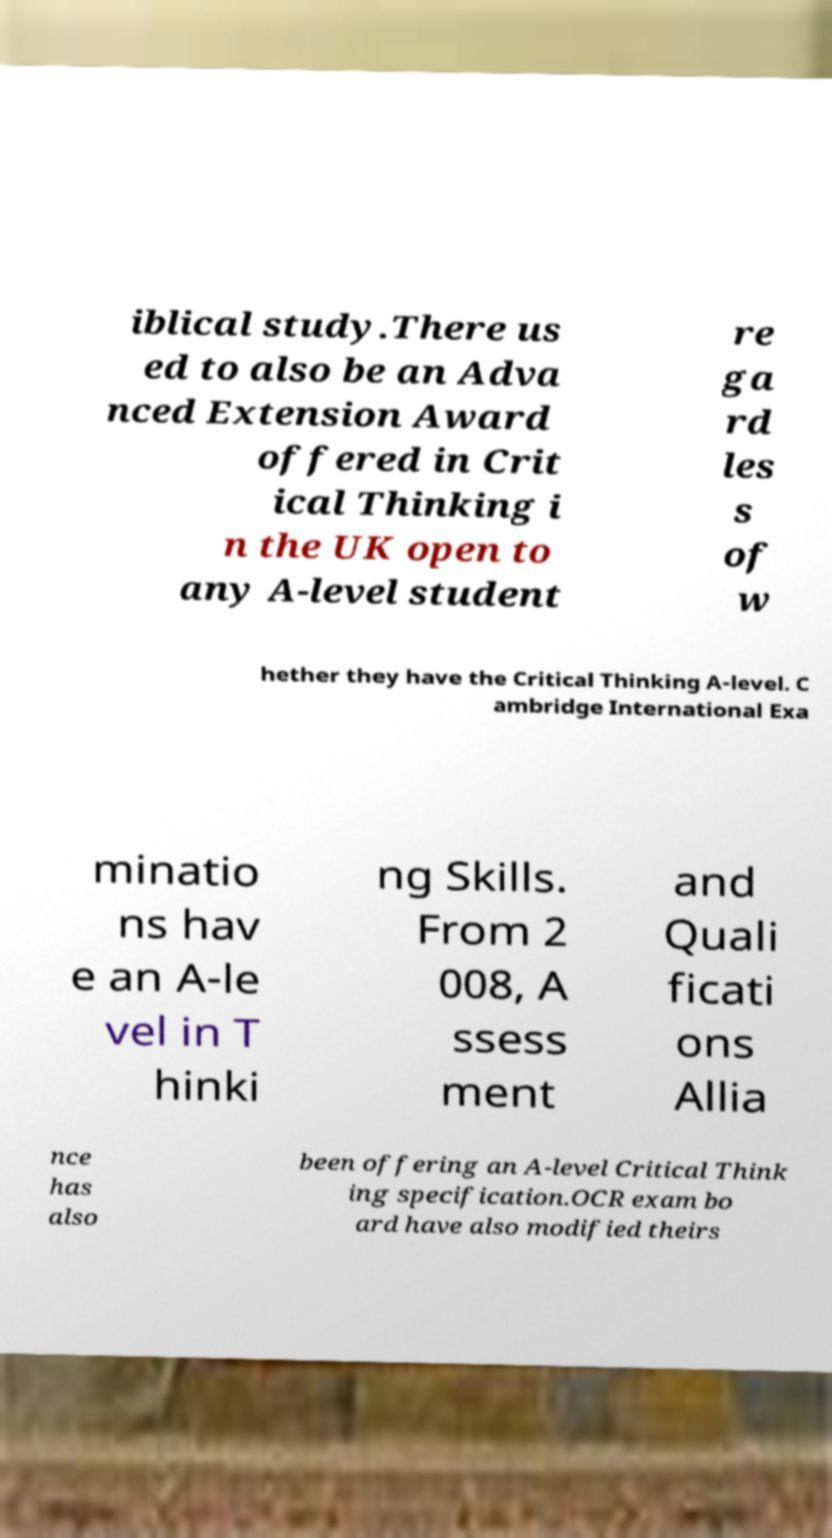Could you assist in decoding the text presented in this image and type it out clearly? iblical study.There us ed to also be an Adva nced Extension Award offered in Crit ical Thinking i n the UK open to any A-level student re ga rd les s of w hether they have the Critical Thinking A-level. C ambridge International Exa minatio ns hav e an A-le vel in T hinki ng Skills. From 2 008, A ssess ment and Quali ficati ons Allia nce has also been offering an A-level Critical Think ing specification.OCR exam bo ard have also modified theirs 